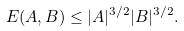<formula> <loc_0><loc_0><loc_500><loc_500>E ( A , B ) \leq | A | ^ { 3 / 2 } | B | ^ { 3 / 2 } .</formula> 